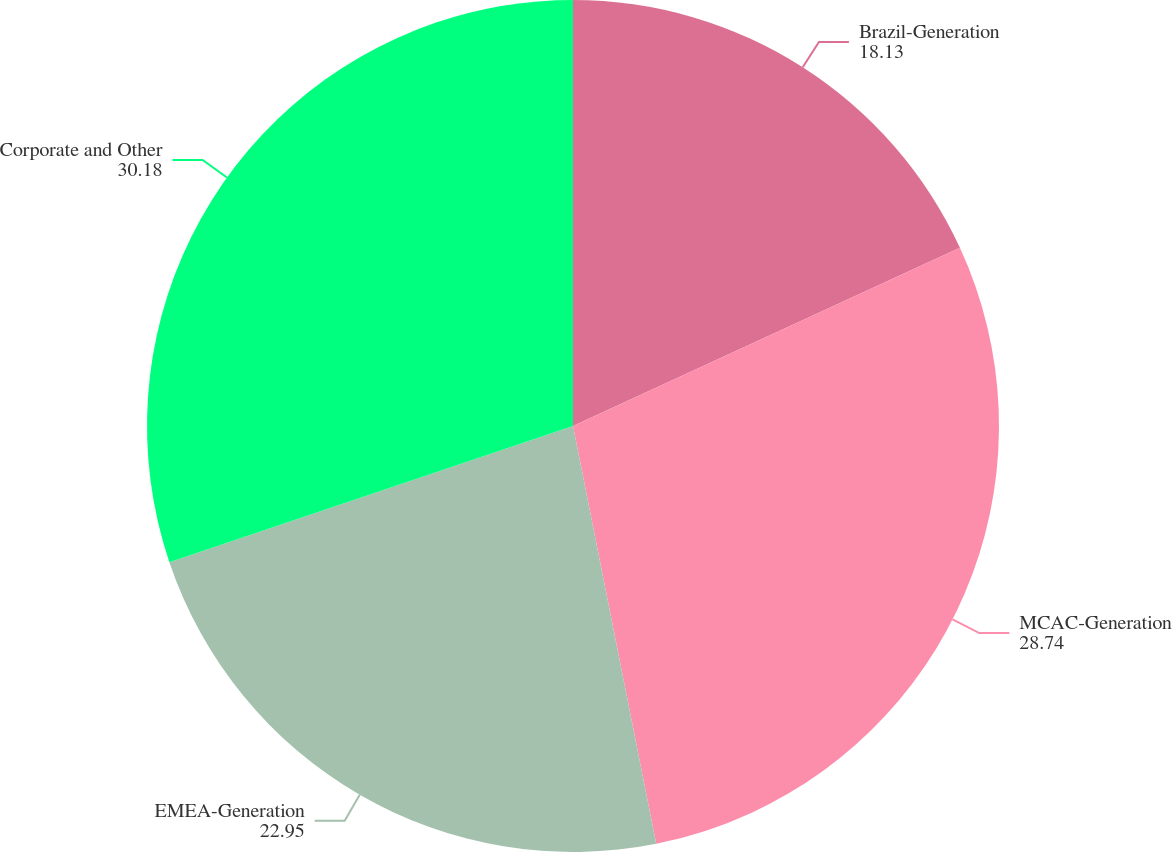Convert chart. <chart><loc_0><loc_0><loc_500><loc_500><pie_chart><fcel>Brazil-Generation<fcel>MCAC-Generation<fcel>EMEA-Generation<fcel>Corporate and Other<nl><fcel>18.13%<fcel>28.74%<fcel>22.95%<fcel>30.18%<nl></chart> 